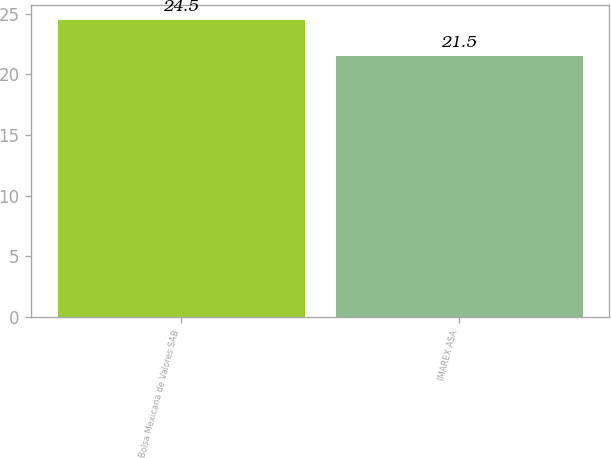Convert chart to OTSL. <chart><loc_0><loc_0><loc_500><loc_500><bar_chart><fcel>Bolsa Mexicana de Valores SAB<fcel>IMAREX ASA<nl><fcel>24.5<fcel>21.5<nl></chart> 